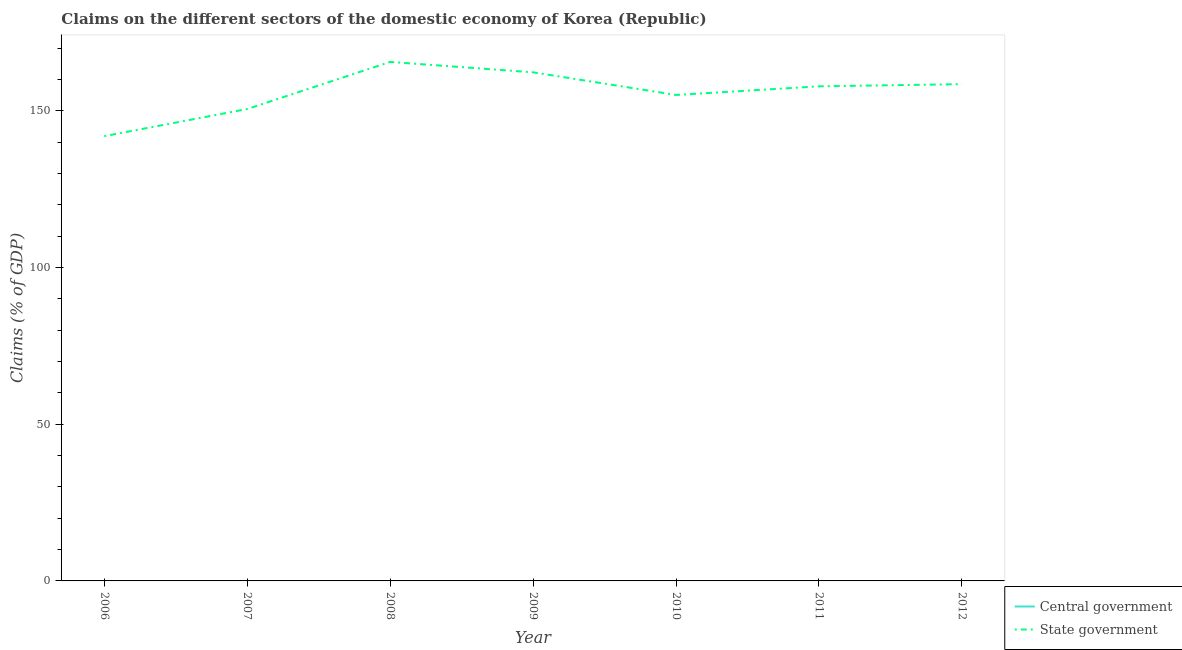How many different coloured lines are there?
Offer a terse response. 1. Does the line corresponding to claims on state government intersect with the line corresponding to claims on central government?
Give a very brief answer. No. Is the number of lines equal to the number of legend labels?
Offer a very short reply. No. What is the claims on state government in 2009?
Your answer should be compact. 162.31. Across all years, what is the maximum claims on state government?
Offer a very short reply. 165.63. Across all years, what is the minimum claims on state government?
Give a very brief answer. 141.94. In which year was the claims on state government maximum?
Provide a short and direct response. 2008. What is the total claims on state government in the graph?
Provide a succinct answer. 1091.94. What is the difference between the claims on state government in 2009 and that in 2012?
Offer a terse response. 3.77. What is the difference between the claims on state government in 2009 and the claims on central government in 2012?
Your answer should be very brief. 162.31. What is the average claims on state government per year?
Make the answer very short. 155.99. What is the ratio of the claims on state government in 2007 to that in 2011?
Give a very brief answer. 0.95. What is the difference between the highest and the second highest claims on state government?
Make the answer very short. 3.32. What is the difference between the highest and the lowest claims on state government?
Your response must be concise. 23.69. Is the sum of the claims on state government in 2008 and 2009 greater than the maximum claims on central government across all years?
Your answer should be very brief. Yes. Is the claims on central government strictly less than the claims on state government over the years?
Make the answer very short. Yes. How are the legend labels stacked?
Offer a very short reply. Vertical. What is the title of the graph?
Provide a succinct answer. Claims on the different sectors of the domestic economy of Korea (Republic). What is the label or title of the Y-axis?
Offer a terse response. Claims (% of GDP). What is the Claims (% of GDP) of State government in 2006?
Keep it short and to the point. 141.94. What is the Claims (% of GDP) in Central government in 2007?
Provide a short and direct response. 0. What is the Claims (% of GDP) of State government in 2007?
Provide a short and direct response. 150.6. What is the Claims (% of GDP) of State government in 2008?
Your answer should be very brief. 165.63. What is the Claims (% of GDP) of Central government in 2009?
Provide a short and direct response. 0. What is the Claims (% of GDP) of State government in 2009?
Provide a short and direct response. 162.31. What is the Claims (% of GDP) in Central government in 2010?
Give a very brief answer. 0. What is the Claims (% of GDP) in State government in 2010?
Offer a terse response. 155.09. What is the Claims (% of GDP) of State government in 2011?
Keep it short and to the point. 157.84. What is the Claims (% of GDP) in Central government in 2012?
Keep it short and to the point. 0. What is the Claims (% of GDP) in State government in 2012?
Give a very brief answer. 158.54. Across all years, what is the maximum Claims (% of GDP) of State government?
Offer a terse response. 165.63. Across all years, what is the minimum Claims (% of GDP) in State government?
Provide a succinct answer. 141.94. What is the total Claims (% of GDP) of Central government in the graph?
Ensure brevity in your answer.  0. What is the total Claims (% of GDP) of State government in the graph?
Your answer should be compact. 1091.94. What is the difference between the Claims (% of GDP) in State government in 2006 and that in 2007?
Provide a short and direct response. -8.66. What is the difference between the Claims (% of GDP) of State government in 2006 and that in 2008?
Give a very brief answer. -23.69. What is the difference between the Claims (% of GDP) in State government in 2006 and that in 2009?
Your answer should be very brief. -20.37. What is the difference between the Claims (% of GDP) in State government in 2006 and that in 2010?
Offer a terse response. -13.15. What is the difference between the Claims (% of GDP) in State government in 2006 and that in 2011?
Give a very brief answer. -15.9. What is the difference between the Claims (% of GDP) of State government in 2006 and that in 2012?
Keep it short and to the point. -16.6. What is the difference between the Claims (% of GDP) in State government in 2007 and that in 2008?
Your answer should be compact. -15.03. What is the difference between the Claims (% of GDP) of State government in 2007 and that in 2009?
Ensure brevity in your answer.  -11.71. What is the difference between the Claims (% of GDP) of State government in 2007 and that in 2010?
Your answer should be very brief. -4.49. What is the difference between the Claims (% of GDP) of State government in 2007 and that in 2011?
Provide a short and direct response. -7.24. What is the difference between the Claims (% of GDP) in State government in 2007 and that in 2012?
Give a very brief answer. -7.94. What is the difference between the Claims (% of GDP) of State government in 2008 and that in 2009?
Keep it short and to the point. 3.32. What is the difference between the Claims (% of GDP) of State government in 2008 and that in 2010?
Your answer should be compact. 10.54. What is the difference between the Claims (% of GDP) of State government in 2008 and that in 2011?
Make the answer very short. 7.79. What is the difference between the Claims (% of GDP) in State government in 2008 and that in 2012?
Offer a very short reply. 7.09. What is the difference between the Claims (% of GDP) of State government in 2009 and that in 2010?
Give a very brief answer. 7.22. What is the difference between the Claims (% of GDP) of State government in 2009 and that in 2011?
Ensure brevity in your answer.  4.47. What is the difference between the Claims (% of GDP) of State government in 2009 and that in 2012?
Your response must be concise. 3.77. What is the difference between the Claims (% of GDP) in State government in 2010 and that in 2011?
Give a very brief answer. -2.75. What is the difference between the Claims (% of GDP) in State government in 2010 and that in 2012?
Ensure brevity in your answer.  -3.45. What is the difference between the Claims (% of GDP) in State government in 2011 and that in 2012?
Your response must be concise. -0.7. What is the average Claims (% of GDP) of State government per year?
Provide a short and direct response. 155.99. What is the ratio of the Claims (% of GDP) of State government in 2006 to that in 2007?
Make the answer very short. 0.94. What is the ratio of the Claims (% of GDP) in State government in 2006 to that in 2008?
Keep it short and to the point. 0.86. What is the ratio of the Claims (% of GDP) of State government in 2006 to that in 2009?
Provide a succinct answer. 0.87. What is the ratio of the Claims (% of GDP) of State government in 2006 to that in 2010?
Ensure brevity in your answer.  0.92. What is the ratio of the Claims (% of GDP) in State government in 2006 to that in 2011?
Your response must be concise. 0.9. What is the ratio of the Claims (% of GDP) in State government in 2006 to that in 2012?
Give a very brief answer. 0.9. What is the ratio of the Claims (% of GDP) of State government in 2007 to that in 2008?
Give a very brief answer. 0.91. What is the ratio of the Claims (% of GDP) of State government in 2007 to that in 2009?
Provide a succinct answer. 0.93. What is the ratio of the Claims (% of GDP) in State government in 2007 to that in 2010?
Provide a short and direct response. 0.97. What is the ratio of the Claims (% of GDP) in State government in 2007 to that in 2011?
Ensure brevity in your answer.  0.95. What is the ratio of the Claims (% of GDP) in State government in 2007 to that in 2012?
Provide a succinct answer. 0.95. What is the ratio of the Claims (% of GDP) in State government in 2008 to that in 2009?
Provide a succinct answer. 1.02. What is the ratio of the Claims (% of GDP) in State government in 2008 to that in 2010?
Offer a very short reply. 1.07. What is the ratio of the Claims (% of GDP) in State government in 2008 to that in 2011?
Provide a short and direct response. 1.05. What is the ratio of the Claims (% of GDP) of State government in 2008 to that in 2012?
Offer a very short reply. 1.04. What is the ratio of the Claims (% of GDP) in State government in 2009 to that in 2010?
Your answer should be compact. 1.05. What is the ratio of the Claims (% of GDP) of State government in 2009 to that in 2011?
Offer a terse response. 1.03. What is the ratio of the Claims (% of GDP) in State government in 2009 to that in 2012?
Offer a very short reply. 1.02. What is the ratio of the Claims (% of GDP) in State government in 2010 to that in 2011?
Offer a very short reply. 0.98. What is the ratio of the Claims (% of GDP) of State government in 2010 to that in 2012?
Offer a terse response. 0.98. What is the ratio of the Claims (% of GDP) in State government in 2011 to that in 2012?
Ensure brevity in your answer.  1. What is the difference between the highest and the second highest Claims (% of GDP) of State government?
Offer a terse response. 3.32. What is the difference between the highest and the lowest Claims (% of GDP) in State government?
Ensure brevity in your answer.  23.69. 